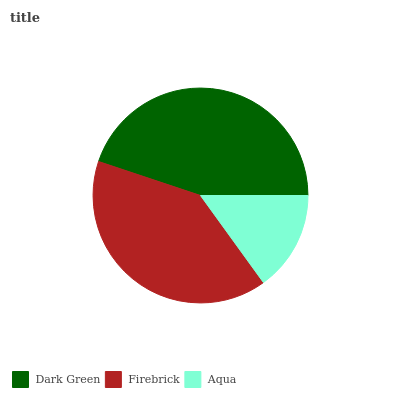Is Aqua the minimum?
Answer yes or no. Yes. Is Dark Green the maximum?
Answer yes or no. Yes. Is Firebrick the minimum?
Answer yes or no. No. Is Firebrick the maximum?
Answer yes or no. No. Is Dark Green greater than Firebrick?
Answer yes or no. Yes. Is Firebrick less than Dark Green?
Answer yes or no. Yes. Is Firebrick greater than Dark Green?
Answer yes or no. No. Is Dark Green less than Firebrick?
Answer yes or no. No. Is Firebrick the high median?
Answer yes or no. Yes. Is Firebrick the low median?
Answer yes or no. Yes. Is Dark Green the high median?
Answer yes or no. No. Is Aqua the low median?
Answer yes or no. No. 